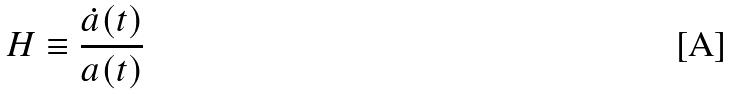Convert formula to latex. <formula><loc_0><loc_0><loc_500><loc_500>H \equiv \frac { \dot { a } ( t ) } { a ( t ) }</formula> 